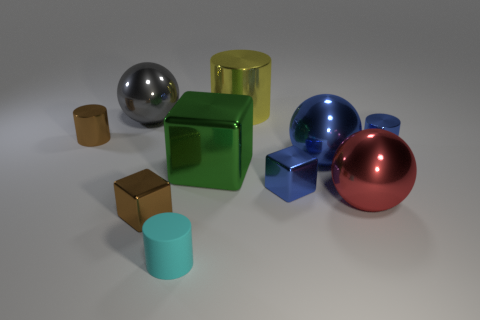Subtract all cubes. How many objects are left? 7 Add 7 tiny cyan objects. How many tiny cyan objects are left? 8 Add 3 cylinders. How many cylinders exist? 7 Subtract 0 red cylinders. How many objects are left? 10 Subtract all green cubes. Subtract all big yellow cylinders. How many objects are left? 8 